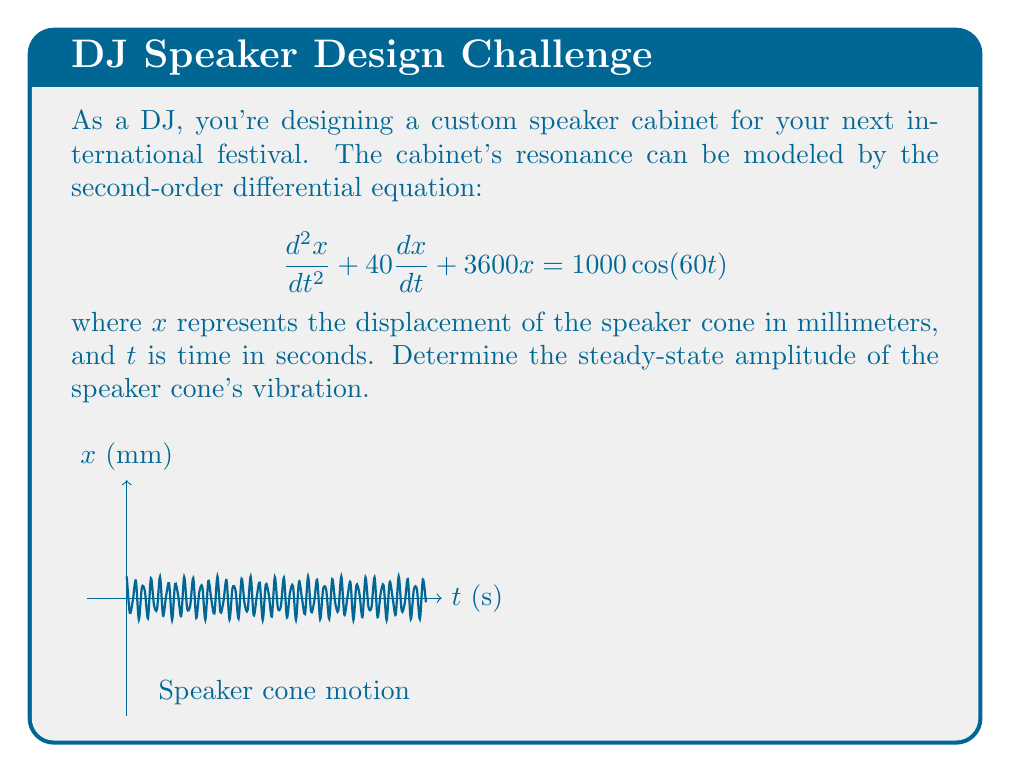Solve this math problem. Let's solve this step-by-step:

1) The general form of a forced vibration equation is:
   $$\frac{d^2x}{dt^2} + 2\zeta\omega_n\frac{dx}{dt} + \omega_n^2x = F_0\cos(\omega t)$$

2) Comparing our equation to this form, we can identify:
   $2\zeta\omega_n = 40$
   $\omega_n^2 = 3600$
   $F_0 = 1000$
   $\omega = 60$

3) We can calculate $\omega_n = \sqrt{3600} = 60$ rad/s

4) The steady-state solution for this system has the form:
   $$x(t) = X\cos(\omega t - \phi)$$

   where $X$ is the amplitude we're looking for.

5) For a second-order system, the amplitude $X$ is given by:
   $$X = \frac{F_0}{\sqrt{(\omega_n^2 - \omega^2)^2 + (2\zeta\omega_n\omega)^2}}$$

6) We need to find $\zeta$. Using $2\zeta\omega_n = 40$ and $\omega_n = 60$:
   $$2\zeta(60) = 40$$
   $$\zeta = \frac{40}{120} = \frac{1}{3}$$

7) Now we can substitute all values into the amplitude equation:
   $$X = \frac{1000}{\sqrt{(3600 - 60^2)^2 + (2 \cdot \frac{1}{3} \cdot 60 \cdot 60)^2}}$$

8) Simplifying:
   $$X = \frac{1000}{\sqrt{3600^2 + 1600^2}} = \frac{1000}{\sqrt{15,520,000}} \approx 0.2778$$

Therefore, the steady-state amplitude of the speaker cone's vibration is approximately 0.2778 mm.
Answer: 0.2778 mm 